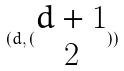Convert formula to latex. <formula><loc_0><loc_0><loc_500><loc_500>( d , ( \begin{matrix} d + 1 \\ 2 \end{matrix} ) )</formula> 